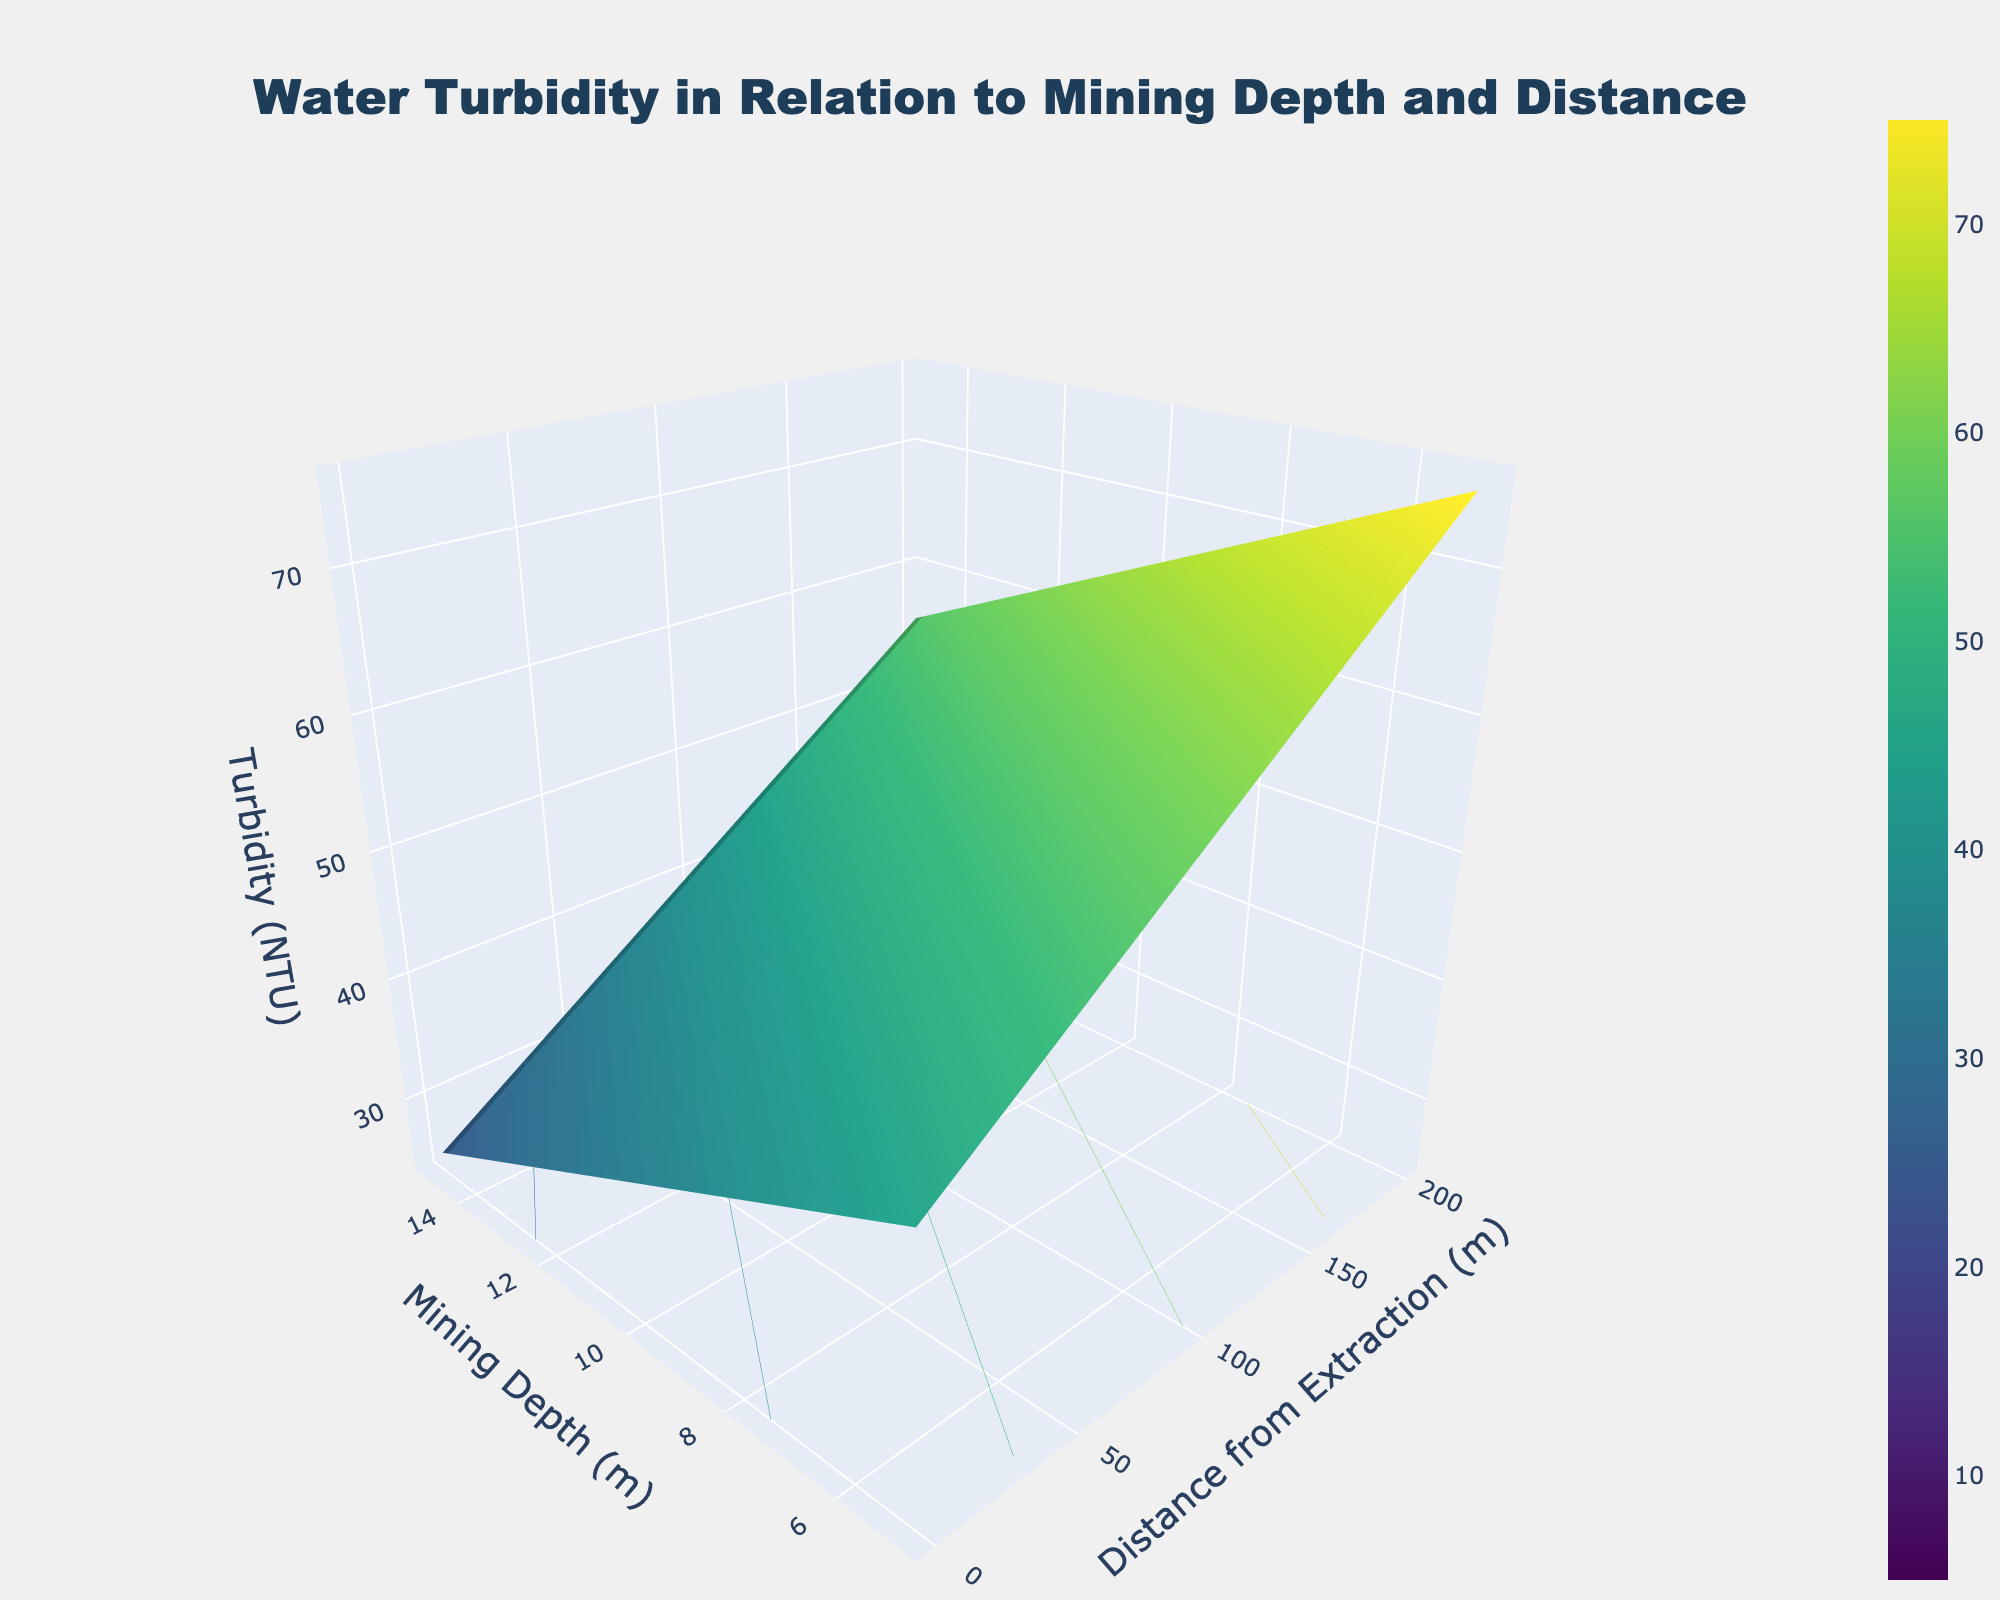What does the title of the plot indicate? The title of the plot is "Water Turbidity in Relation to Mining Depth and Distance," which suggests that the plot displays how water turbidity changes depending on different mining depths and distances from extraction points.
Answer: Water Turbidity in Relation to Mining Depth and Distance What are the axes labeled in the plot? The x-axis is labeled "Distance from Extraction (m)," the y-axis is labeled "Mining Depth (m)," and the z-axis is labeled "Turbidity (NTU)."
Answer: Distance from Extraction, Mining Depth, Turbidity What is the observed trend in turbidity as the mining depth increases at a constant distance of 100 meters? By examining the surface plot at the distance of 100 meters, we see that turbidity increases with mining depth: from 35 NTU at 5 meters, to 50 NTU at 10 meters, and to 65 NTU at 15 meters.
Answer: Increases At what mining depth and distance does the lowest turbidity occur, and what is its value? To find this, we look at the entire surface plot and see that the lowest turbidity value is 5 NTU, which occurs at a mining depth of 5 meters and a distance of 500 meters from extraction.
Answer: 5 meters depth, 500 meters distance, 5 NTU Compare the turbidity values between mining depths of 5 meters and 15 meters at 300 meters distance. Which is higher? At a distance of 300 meters, the turbidity is 15 NTU at a mining depth of 5 meters and 45 NTU at a depth of 15 meters, indicating the turbidity is higher at the depth of 15 meters.
Answer: 15 meters depth Calculate the difference in turbidity between the distances of 0 meters and 300 meters from extraction at a mining depth of 10 meters. At a mining depth of 10 meters, the turbidity at 0 meters distance is 60 NTU and at 300 meters distance is 30 NTU. The difference in turbidity is 60 - 30 = 30 NTU.
Answer: 30 NTU As one moves further from the extraction point, how does turbidity change at a constant mining depth of 5 meters? Observing the surface plot at 5 meters depth, turbidity decreases as the distance from extraction increases: from 45 NTU at 0 meters to 5 NTU at 500 meters.
Answer: Decreases Is the turbidity value the same at any two mining depths for a given distance from extraction? By reviewing the plot, we can see that for any given distance, the turbidity values differ at each mining depth.
Answer: No How does the color on the plot represent turbidity values? The color scale on the plot shifts from light colors representing lower turbidity values to darker colors indicating higher turbidity values as seen in the Viridis color scheme.
Answer: Light to Dark 